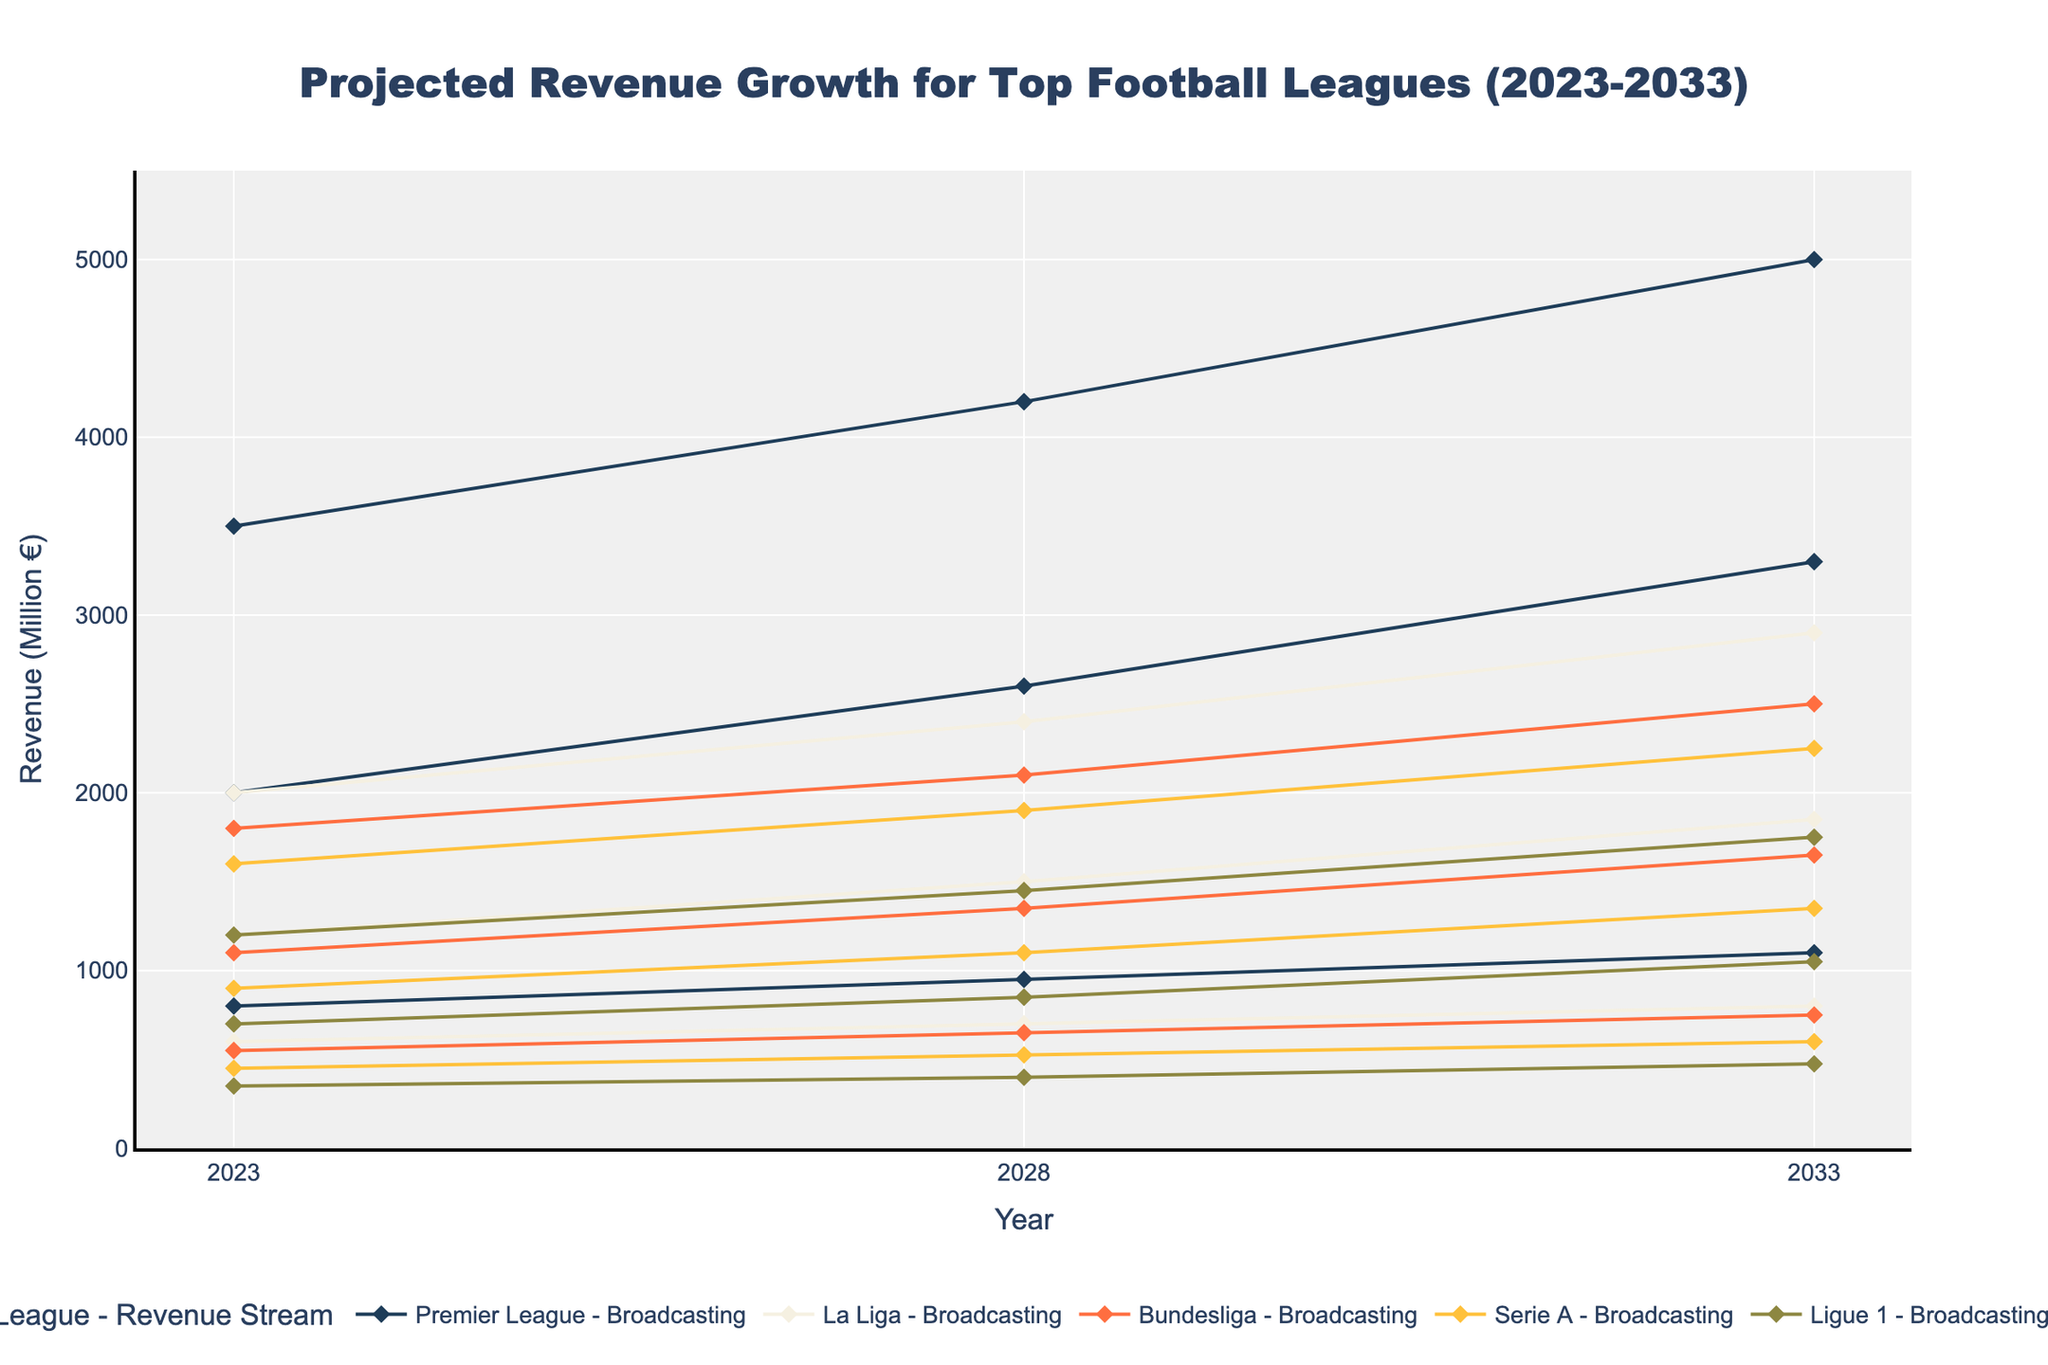what is the range of years displayed in the figure? The range of years is shown on the x-axis of the figure. From the axis labels, we can see that the years range from 2023 to 2033.
Answer: 2023 to 2033 What is the highest projected revenue for the Premier League in 2033? By looking at the data points for the Premier League in 2033, we see that the highest projected revenue comes from Commercial revenue, which is 3300 million €.
Answer: 3300 million € How much more revenue is projected from Broadcasting for the Bundesliga in 2033 compared to 2023? For 2033, the Broadcasting revenue for the Bundesliga is 2500 million €, and for 2023, it is 1800 million €. The difference is calculated as 2500 - 1800 = 700.
Answer: 700 million € Which league is projected to have the least Matchday revenue in 2028? By comparing the Matchday revenues for all leagues in 2028, we see that Ligue 1 has the least revenue with 400 million €.
Answer: Ligue 1 What is the average projected Commercial revenue for Serie A across the years displayed? To calculate the average, we sum the values of Commercial revenue for Serie A across the years 2023 (900), 2028 (1100), and 2033 (1350) and divide by the number of years. (900 + 1100 + 1350) / 3 = 3350 / 3 = 1116.67 million €.
Answer: 1116.67 million € Which revenue stream is projected to have the highest growth for La Liga from 2023 to 2033? The growth for each stream is calculated separately: Broadcasting (2900 - 2000 = 900), Matchday (800 - 600 = 200), and Commercial (1850 - 1200 = 650). The Broadcasting stream has the highest growth.
Answer: Broadcasting In which year is the projected total revenue for Ligue 1 the highest? Sum up the revenues for each year for Ligue 1: 
2023 = 1200 + 350 + 700 = 2250,
2028 = 1450 + 400 + 850 = 2700,
2033 = 1750 + 475 + 1050 = 3275.
The total revenue is highest in 2033.
Answer: 2033 What is the trend in projected Commercial revenue for La Liga from 2023 to 2033? Observing the data points for La Liga's Commercial revenue, it increases from 2023 (1200), 2028 (1500), to 2033 (1850). This indicates a consistent upward trend in Commercial revenue.
Answer: Upward trend What is the projected Broadcasting revenue for Serie A in 2028 and how does this compare to Ligue 1's Broadcasting revenue in the same year? The Broadcasting revenue for Serie A in 2028 is 1900 million €, and for Ligue 1, it is 1450 million €. Serie A's Broadcasting revenue is 450 million € more than Ligue 1's.
Answer: 1900 million €, 450 million € more How much is the combined projected Commercial revenue for the Premier League across all years provided? Sum the Commercial revenue values for the Premier League across the years: 2023 (2000) + 2028 (2600) + 2033 (3300) = 7900 million €.
Answer: 7900 million € 